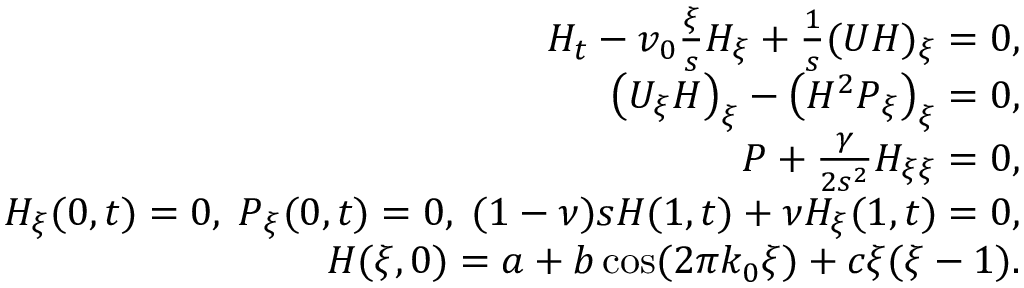Convert formula to latex. <formula><loc_0><loc_0><loc_500><loc_500>\begin{array} { r } { H _ { t } - v _ { 0 } \frac { \xi } { s } H _ { \xi } + \frac { 1 } { s } ( U H ) _ { \xi } = 0 , } \\ { \left ( U _ { \xi } H \right ) _ { \xi } - \left ( H ^ { 2 } P _ { \xi } \right ) _ { \xi } = 0 , } \\ { P + \frac { \gamma } { 2 s ^ { 2 } } H _ { \xi \xi } = 0 , } \\ { H _ { \xi } ( 0 , t ) = 0 , \, P _ { \xi } ( 0 , t ) = 0 , \, ( 1 - \nu ) s H ( 1 , t ) + \nu H _ { \xi } ( 1 , t ) = 0 , } \\ { H ( \xi , 0 ) = a + b \cos ( 2 \pi k _ { 0 } \xi ) + c \xi ( \xi - 1 ) . } \end{array}</formula> 